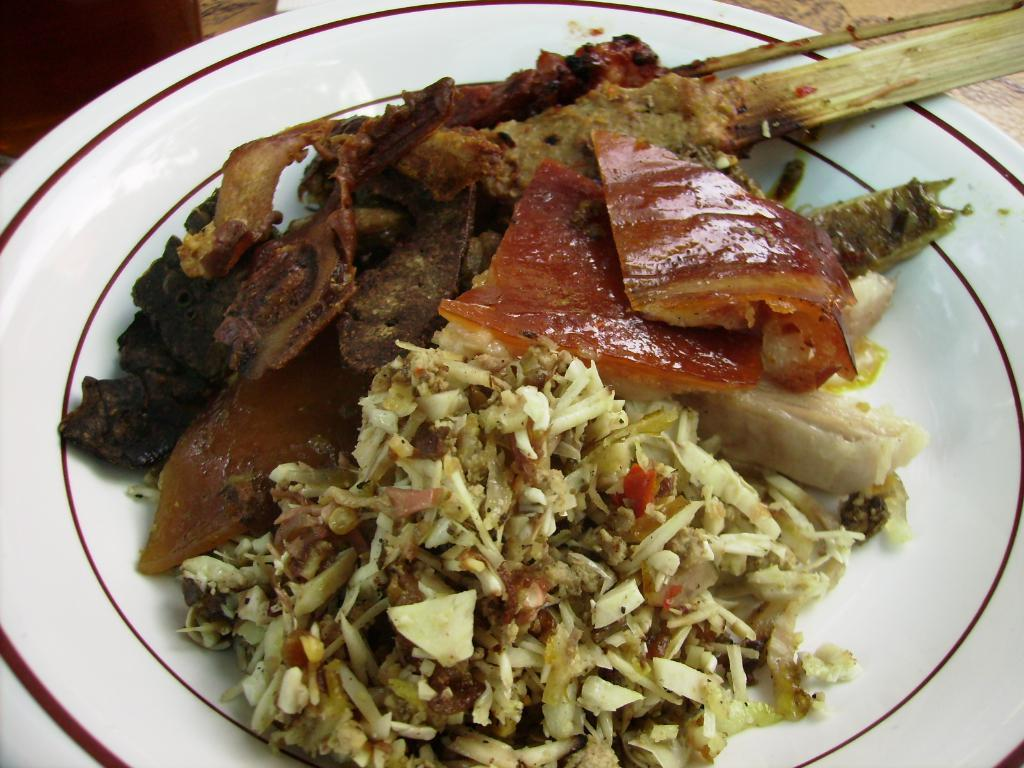What is on the plate that is visible in the image? There is food on a plate in the image. What color is the plate? The plate is white. Where is the plate located in the image? The plate is placed on a brown table. How many dolls are sitting in the middle of the plate in the image? There are no dolls present in the image; it features a plate of food on a brown table. 